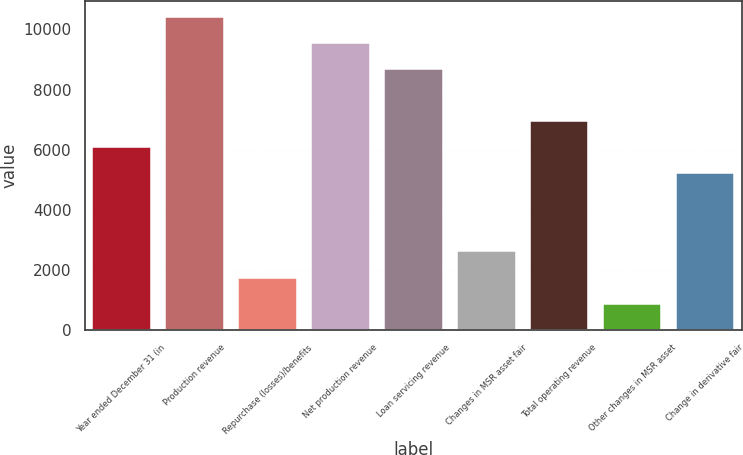Convert chart. <chart><loc_0><loc_0><loc_500><loc_500><bar_chart><fcel>Year ended December 31 (in<fcel>Production revenue<fcel>Repurchase (losses)/benefits<fcel>Net production revenue<fcel>Loan servicing revenue<fcel>Changes in MSR asset fair<fcel>Total operating revenue<fcel>Other changes in MSR asset<fcel>Change in derivative fair<nl><fcel>6083<fcel>10423<fcel>1743<fcel>9555<fcel>8687<fcel>2611<fcel>6951<fcel>875<fcel>5215<nl></chart> 